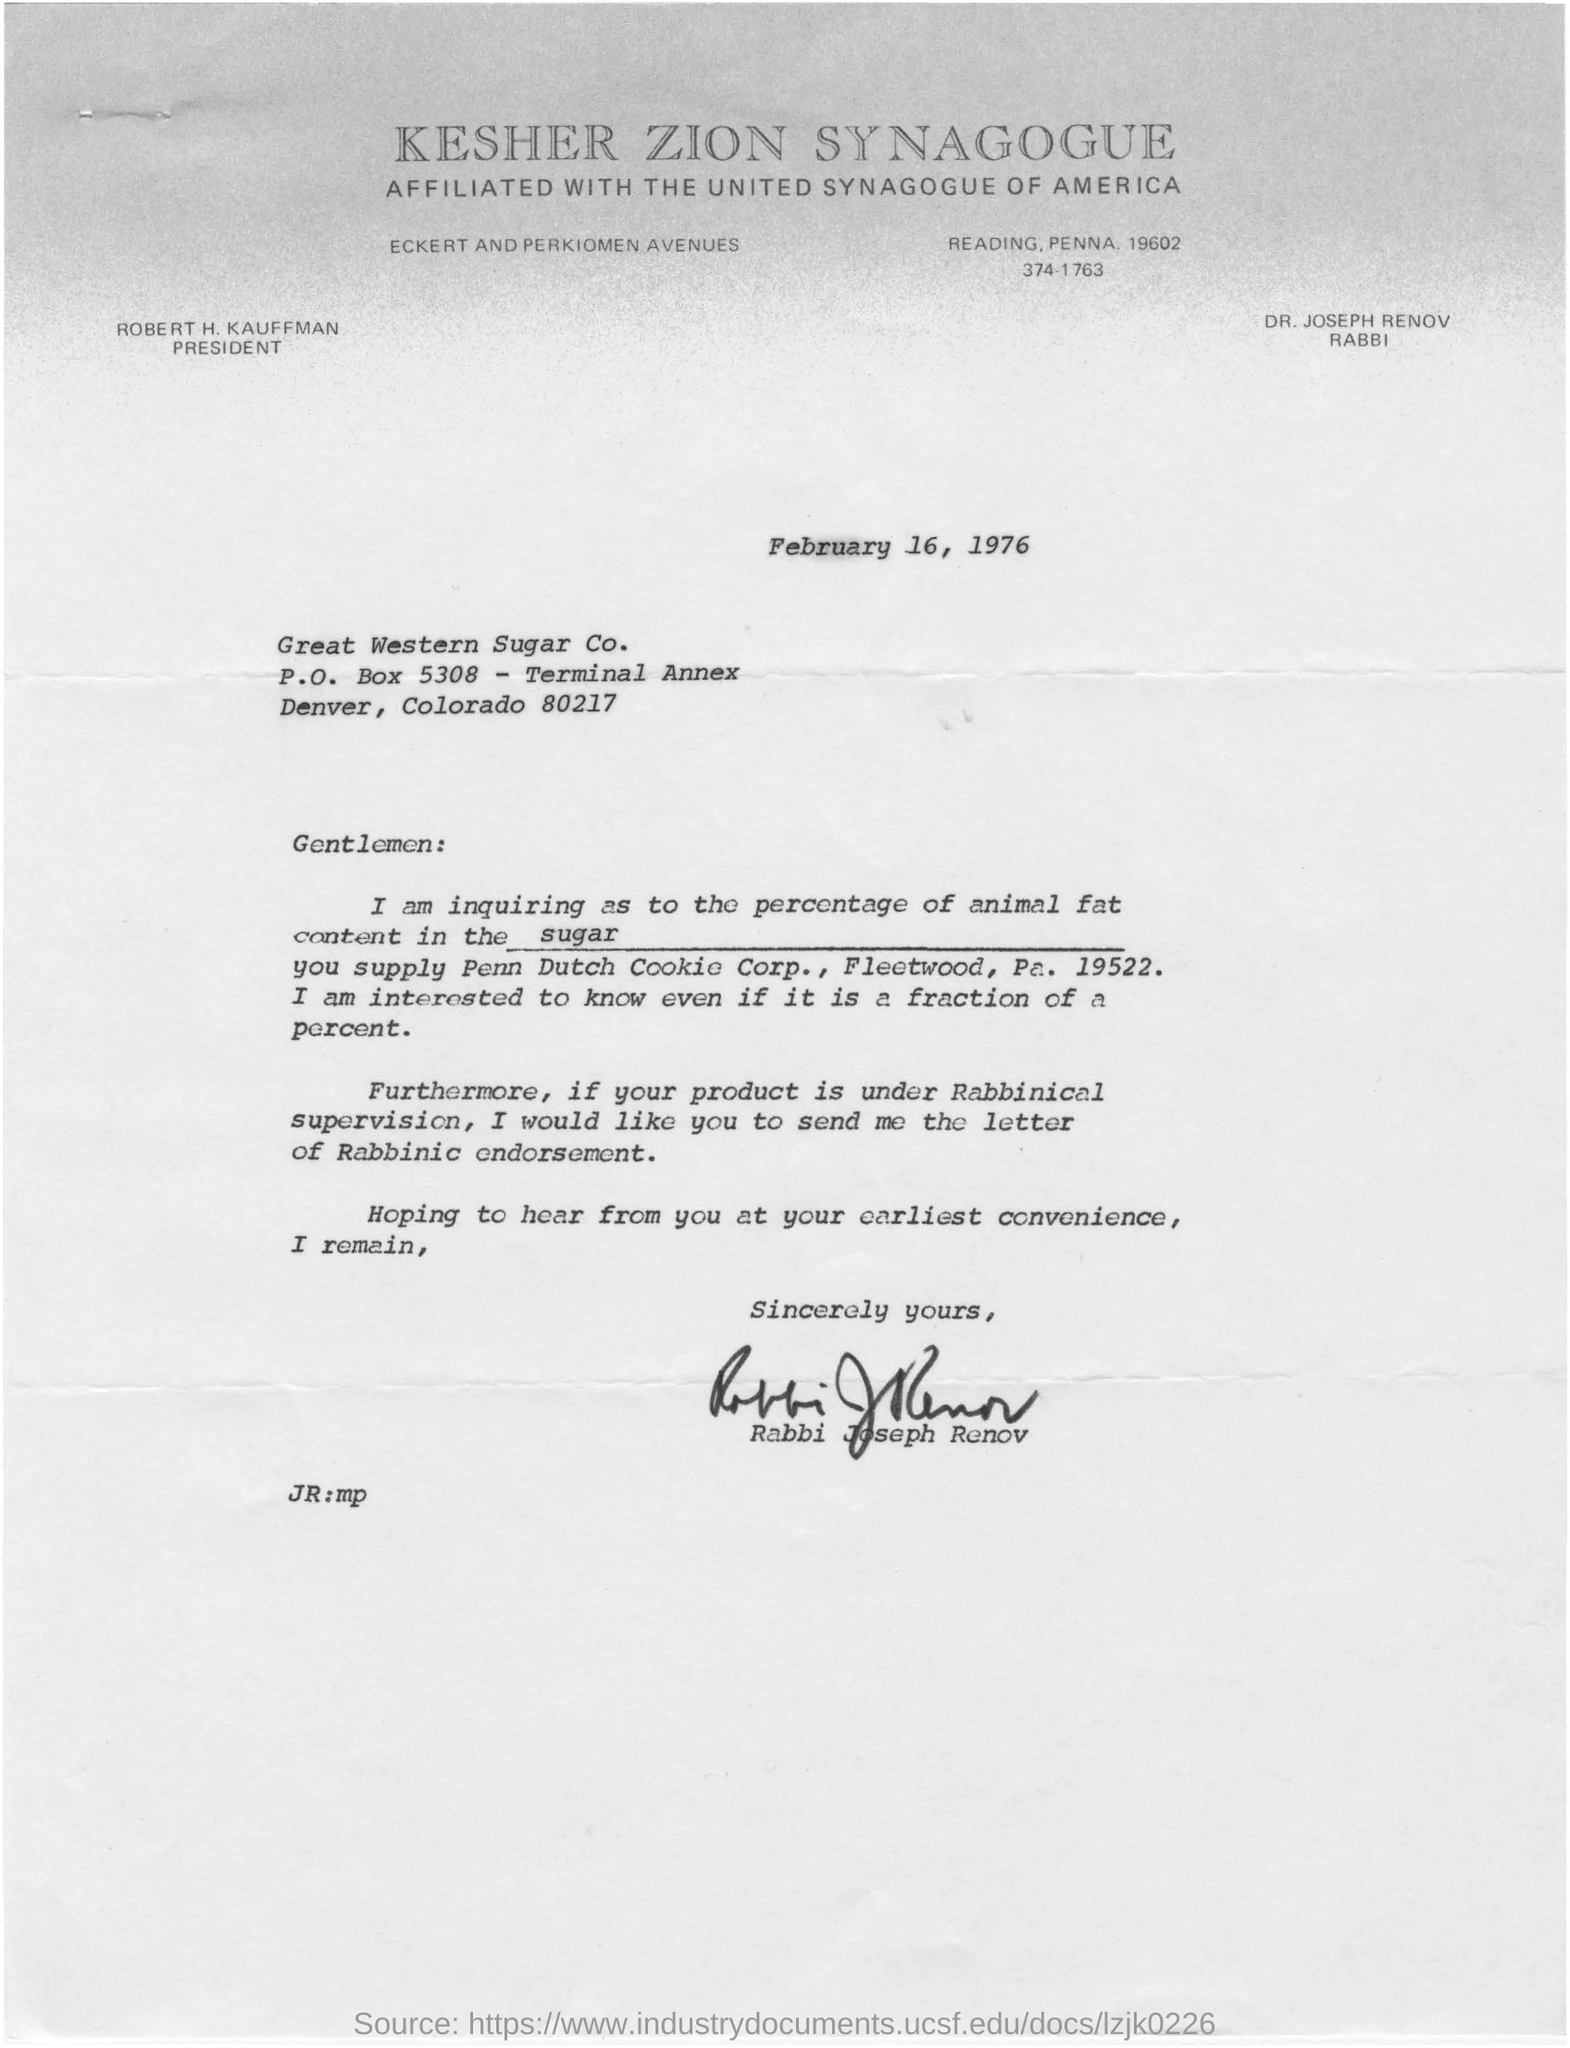Highlight a few significant elements in this photo. The document is written by Rabbi Joseph Renov. The heading of the document is KESHER ZION SYNAGOGUE. The writer is inquiring about the percentage of animal fat in sugar. 